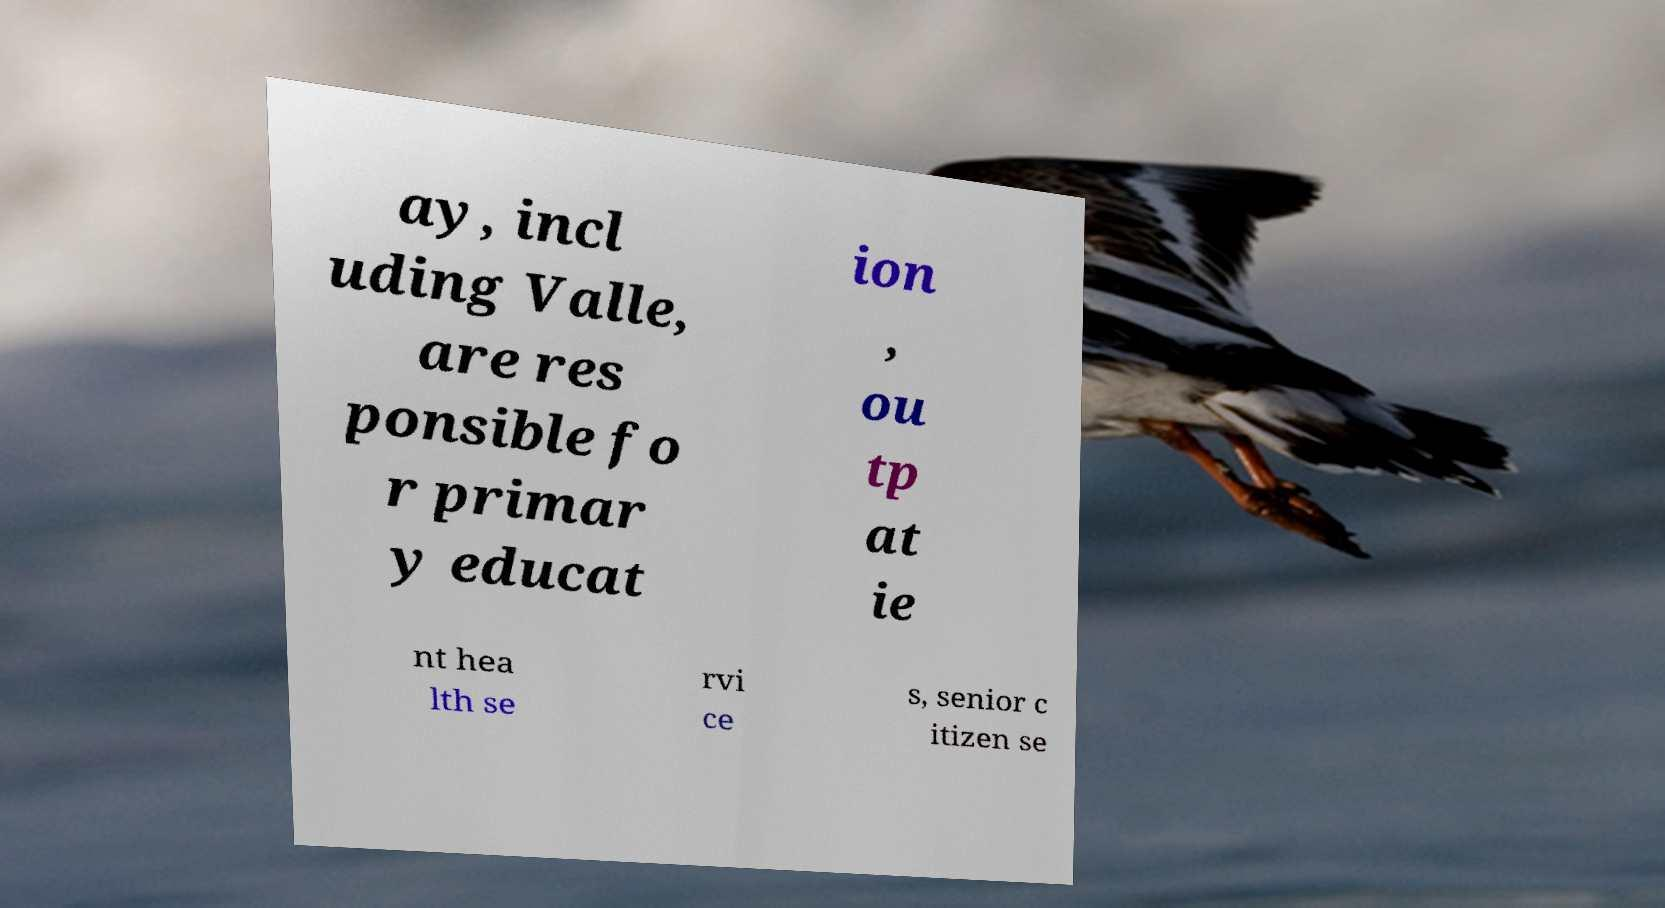For documentation purposes, I need the text within this image transcribed. Could you provide that? ay, incl uding Valle, are res ponsible fo r primar y educat ion , ou tp at ie nt hea lth se rvi ce s, senior c itizen se 